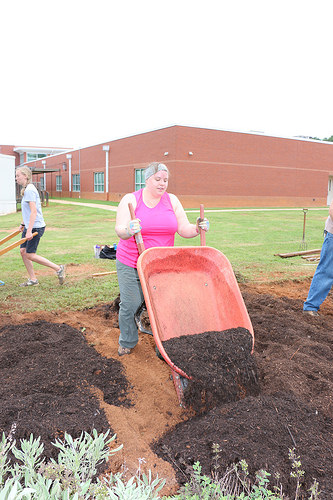<image>
Is there a woman in front of the wheel barrow? No. The woman is not in front of the wheel barrow. The spatial positioning shows a different relationship between these objects. Where is the wheel barrow in relation to the soil? Is it above the soil? Yes. The wheel barrow is positioned above the soil in the vertical space, higher up in the scene. 